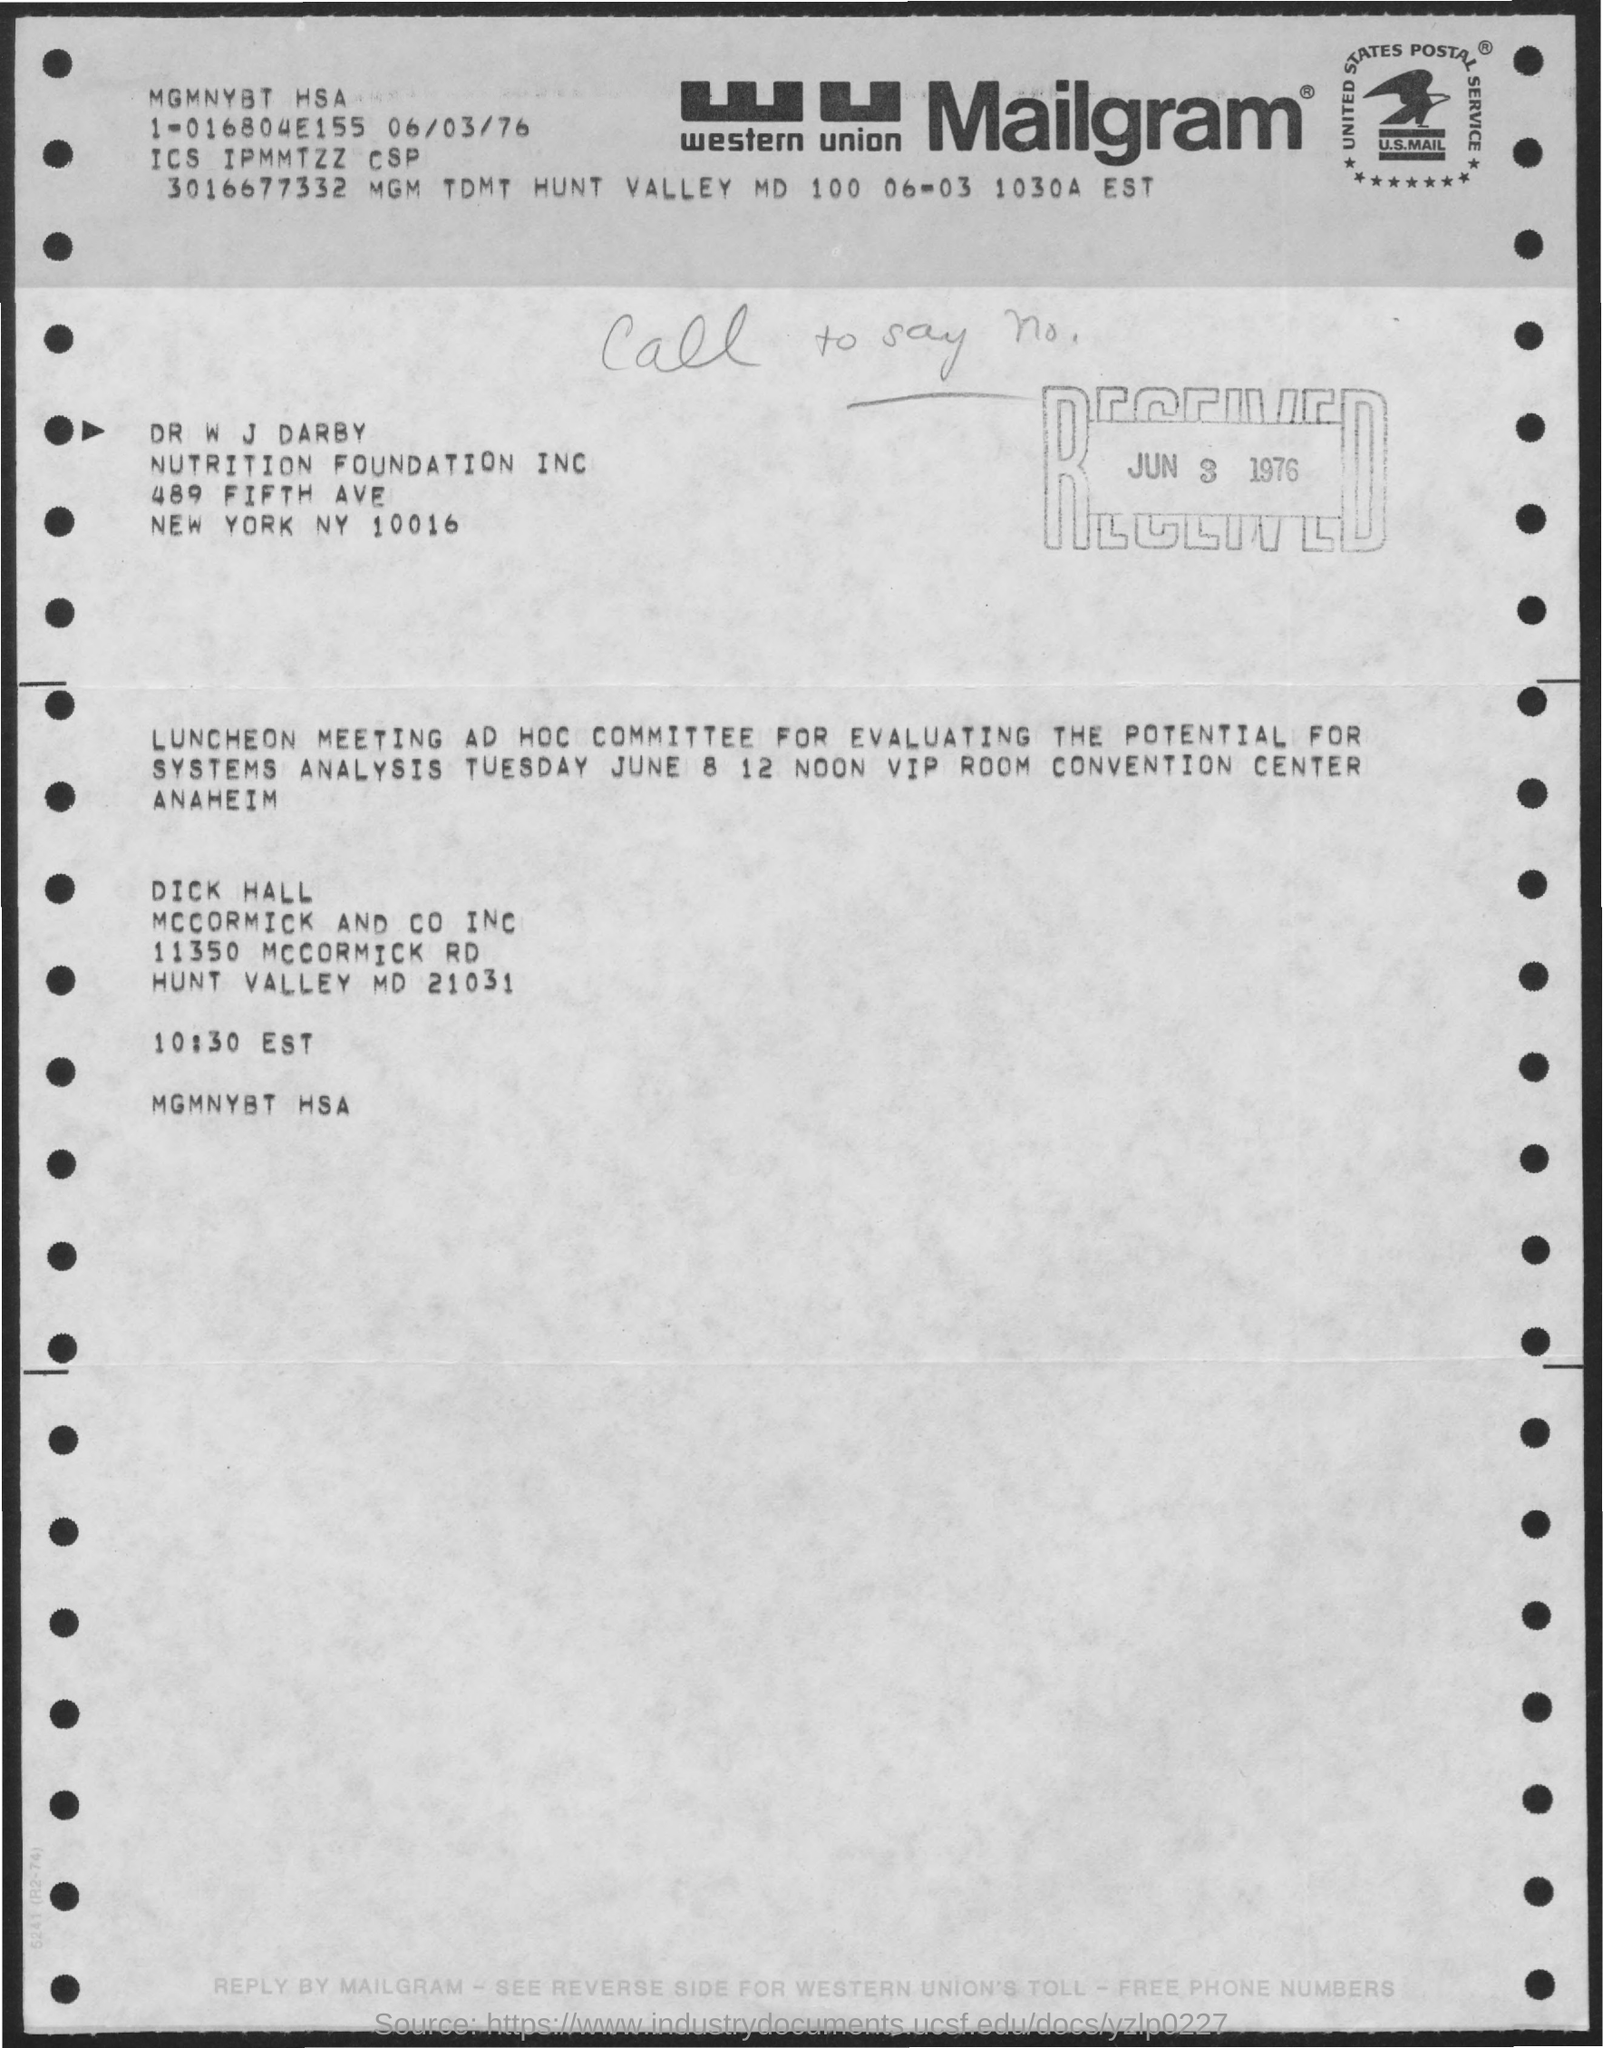Mention a couple of crucial points in this snapshot. Western Union is a company that provides financial services, including money transfers, and the abbreviation "WU" is commonly used to refer to the company. The document mentions that Tuesday is the day of the week. 